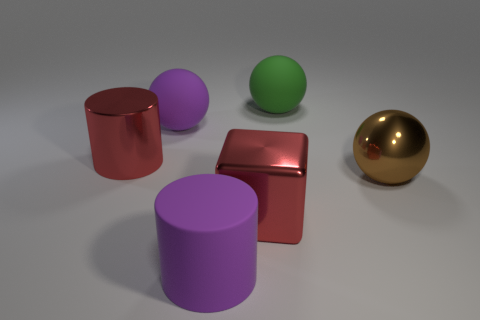Do the metallic cylinder and the big matte cylinder have the same color? no 